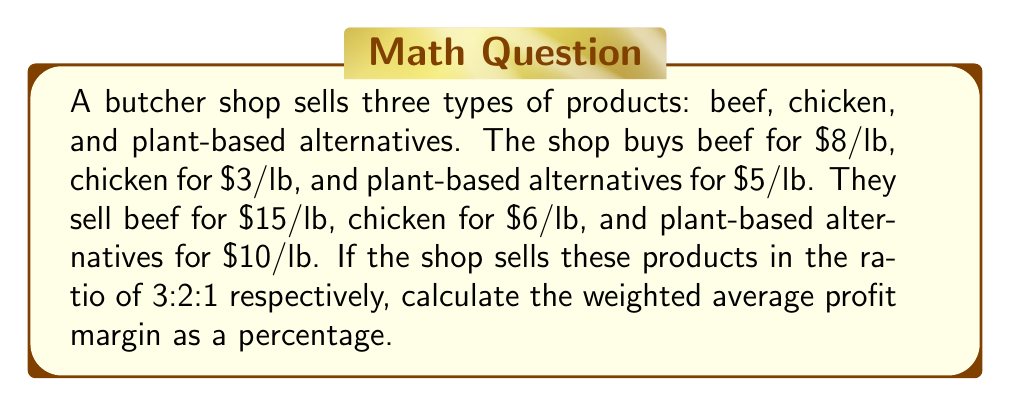Give your solution to this math problem. Let's approach this step-by-step:

1) First, calculate the profit margin for each product:

   Beef: $15 - $8 = $7 profit per lb
   Chicken: $6 - $3 = $3 profit per lb
   Plant-based: $10 - $5 = $5 profit per lb

2) Calculate the profit margin percentage for each:

   Beef: $\frac{7}{15} \times 100\% = 46.67\%$
   Chicken: $\frac{3}{6} \times 100\% = 50\%$
   Plant-based: $\frac{5}{10} \times 100\% = 50\%$

3) The ratio of sales is 3:2:1, so out of every 6 units sold:
   3 are beef, 2 are chicken, and 1 is plant-based

4) Calculate the weighted average:

   $$\frac{(3 \times 46.67\%) + (2 \times 50\%) + (1 \times 50\%)}{3 + 2 + 1}$$

5) Simplify:

   $$\frac{140.01\% + 100\% + 50\%}{6} = \frac{290.01\%}{6} = 48.335\%$$

Therefore, the weighted average profit margin is approximately 48.34%.
Answer: 48.34% 